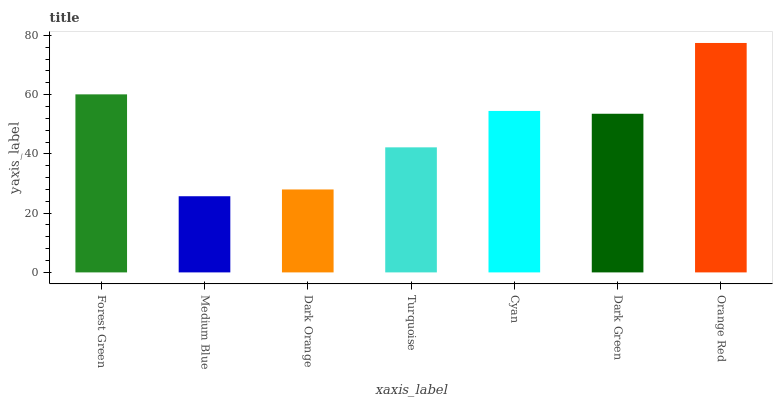Is Medium Blue the minimum?
Answer yes or no. Yes. Is Orange Red the maximum?
Answer yes or no. Yes. Is Dark Orange the minimum?
Answer yes or no. No. Is Dark Orange the maximum?
Answer yes or no. No. Is Dark Orange greater than Medium Blue?
Answer yes or no. Yes. Is Medium Blue less than Dark Orange?
Answer yes or no. Yes. Is Medium Blue greater than Dark Orange?
Answer yes or no. No. Is Dark Orange less than Medium Blue?
Answer yes or no. No. Is Dark Green the high median?
Answer yes or no. Yes. Is Dark Green the low median?
Answer yes or no. Yes. Is Turquoise the high median?
Answer yes or no. No. Is Orange Red the low median?
Answer yes or no. No. 